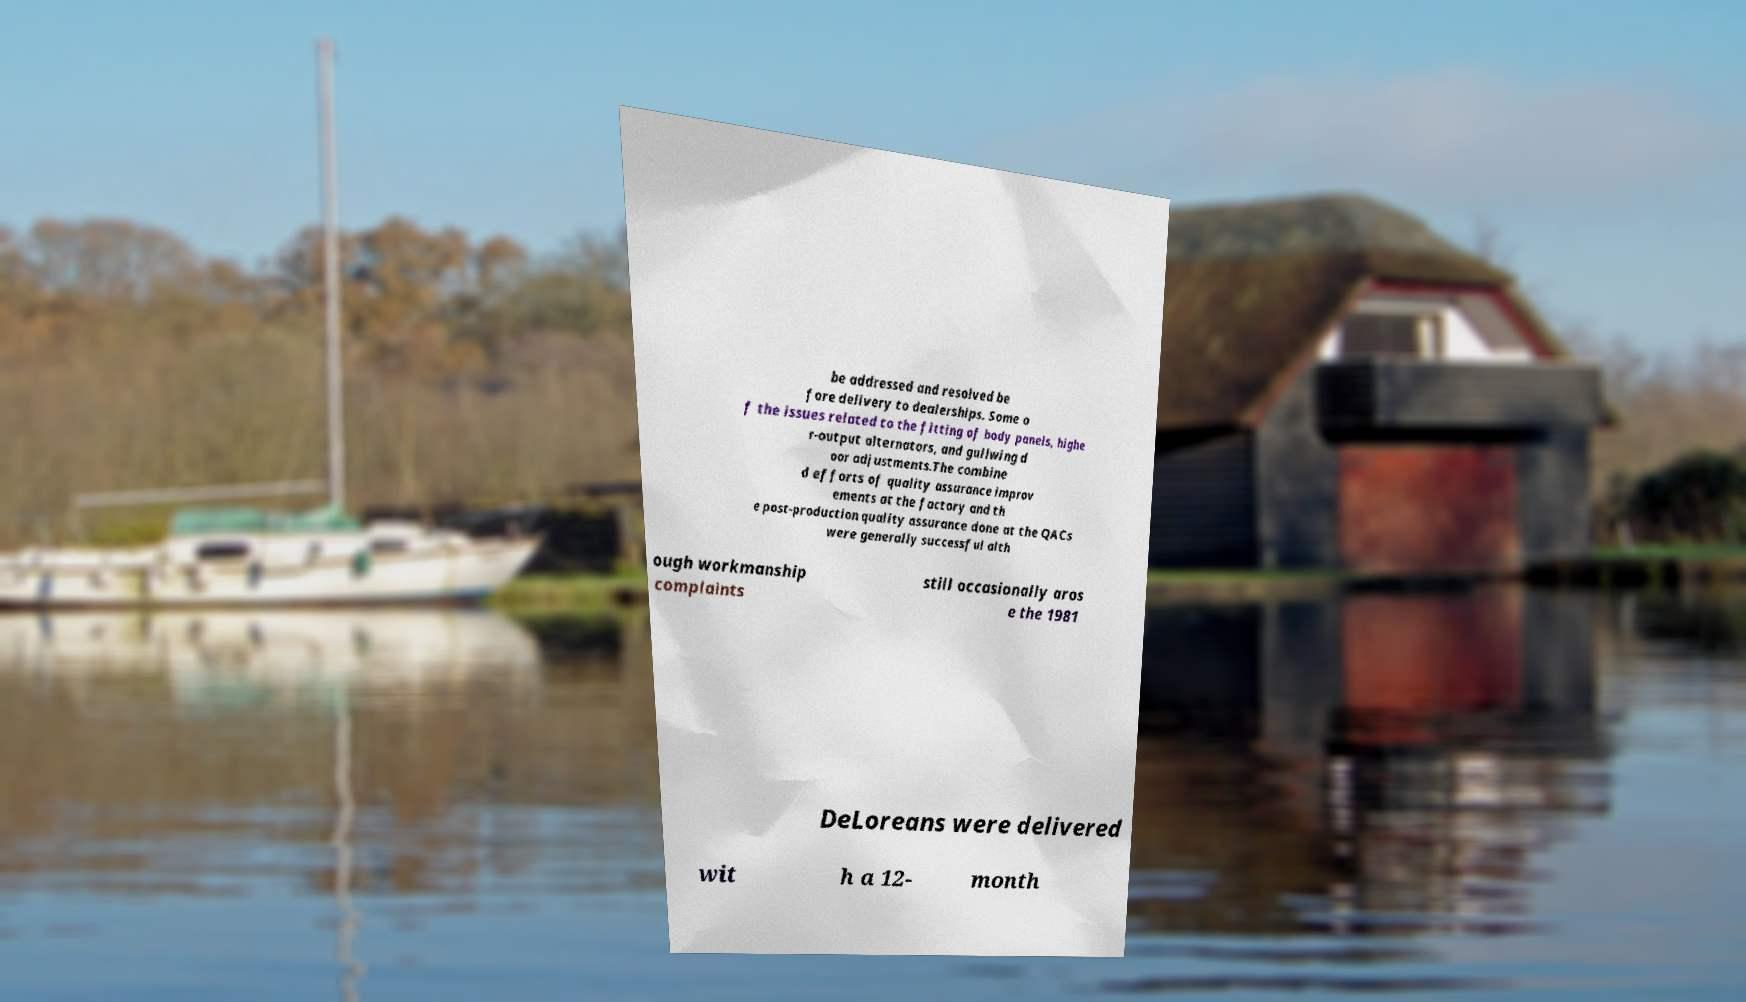I need the written content from this picture converted into text. Can you do that? be addressed and resolved be fore delivery to dealerships. Some o f the issues related to the fitting of body panels, highe r-output alternators, and gullwing d oor adjustments.The combine d efforts of quality assurance improv ements at the factory and th e post-production quality assurance done at the QACs were generally successful alth ough workmanship complaints still occasionally aros e the 1981 DeLoreans were delivered wit h a 12- month 